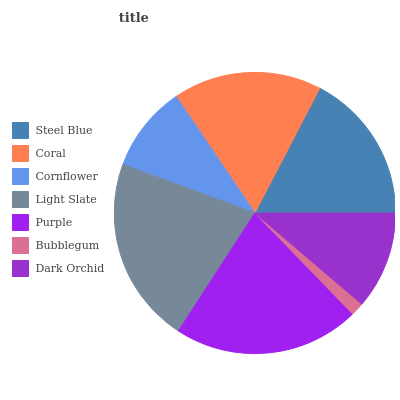Is Bubblegum the minimum?
Answer yes or no. Yes. Is Light Slate the maximum?
Answer yes or no. Yes. Is Coral the minimum?
Answer yes or no. No. Is Coral the maximum?
Answer yes or no. No. Is Steel Blue greater than Coral?
Answer yes or no. Yes. Is Coral less than Steel Blue?
Answer yes or no. Yes. Is Coral greater than Steel Blue?
Answer yes or no. No. Is Steel Blue less than Coral?
Answer yes or no. No. Is Coral the high median?
Answer yes or no. Yes. Is Coral the low median?
Answer yes or no. Yes. Is Light Slate the high median?
Answer yes or no. No. Is Steel Blue the low median?
Answer yes or no. No. 